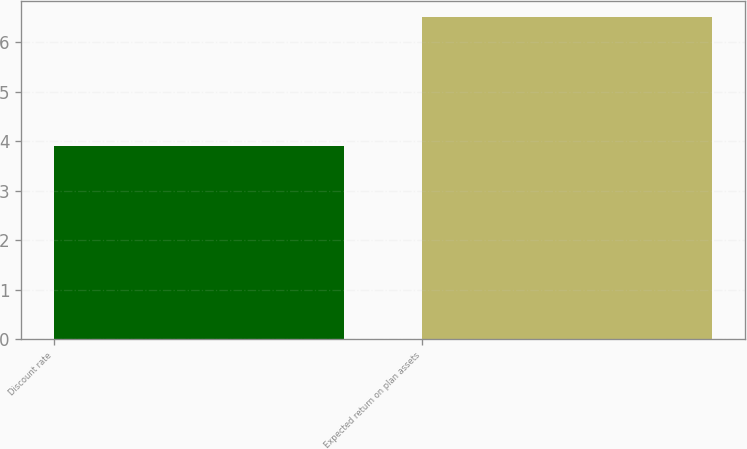Convert chart to OTSL. <chart><loc_0><loc_0><loc_500><loc_500><bar_chart><fcel>Discount rate<fcel>Expected return on plan assets<nl><fcel>3.9<fcel>6.5<nl></chart> 